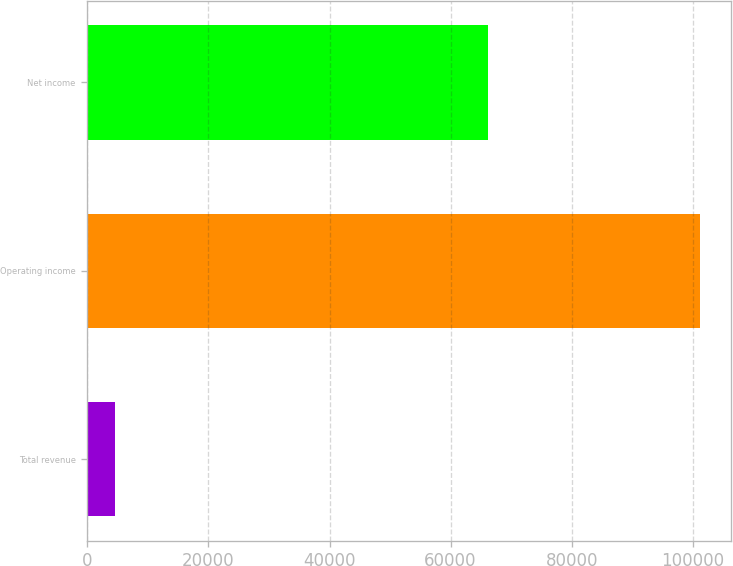Convert chart. <chart><loc_0><loc_0><loc_500><loc_500><bar_chart><fcel>Total revenue<fcel>Operating income<fcel>Net income<nl><fcel>4632<fcel>101232<fcel>66197<nl></chart> 